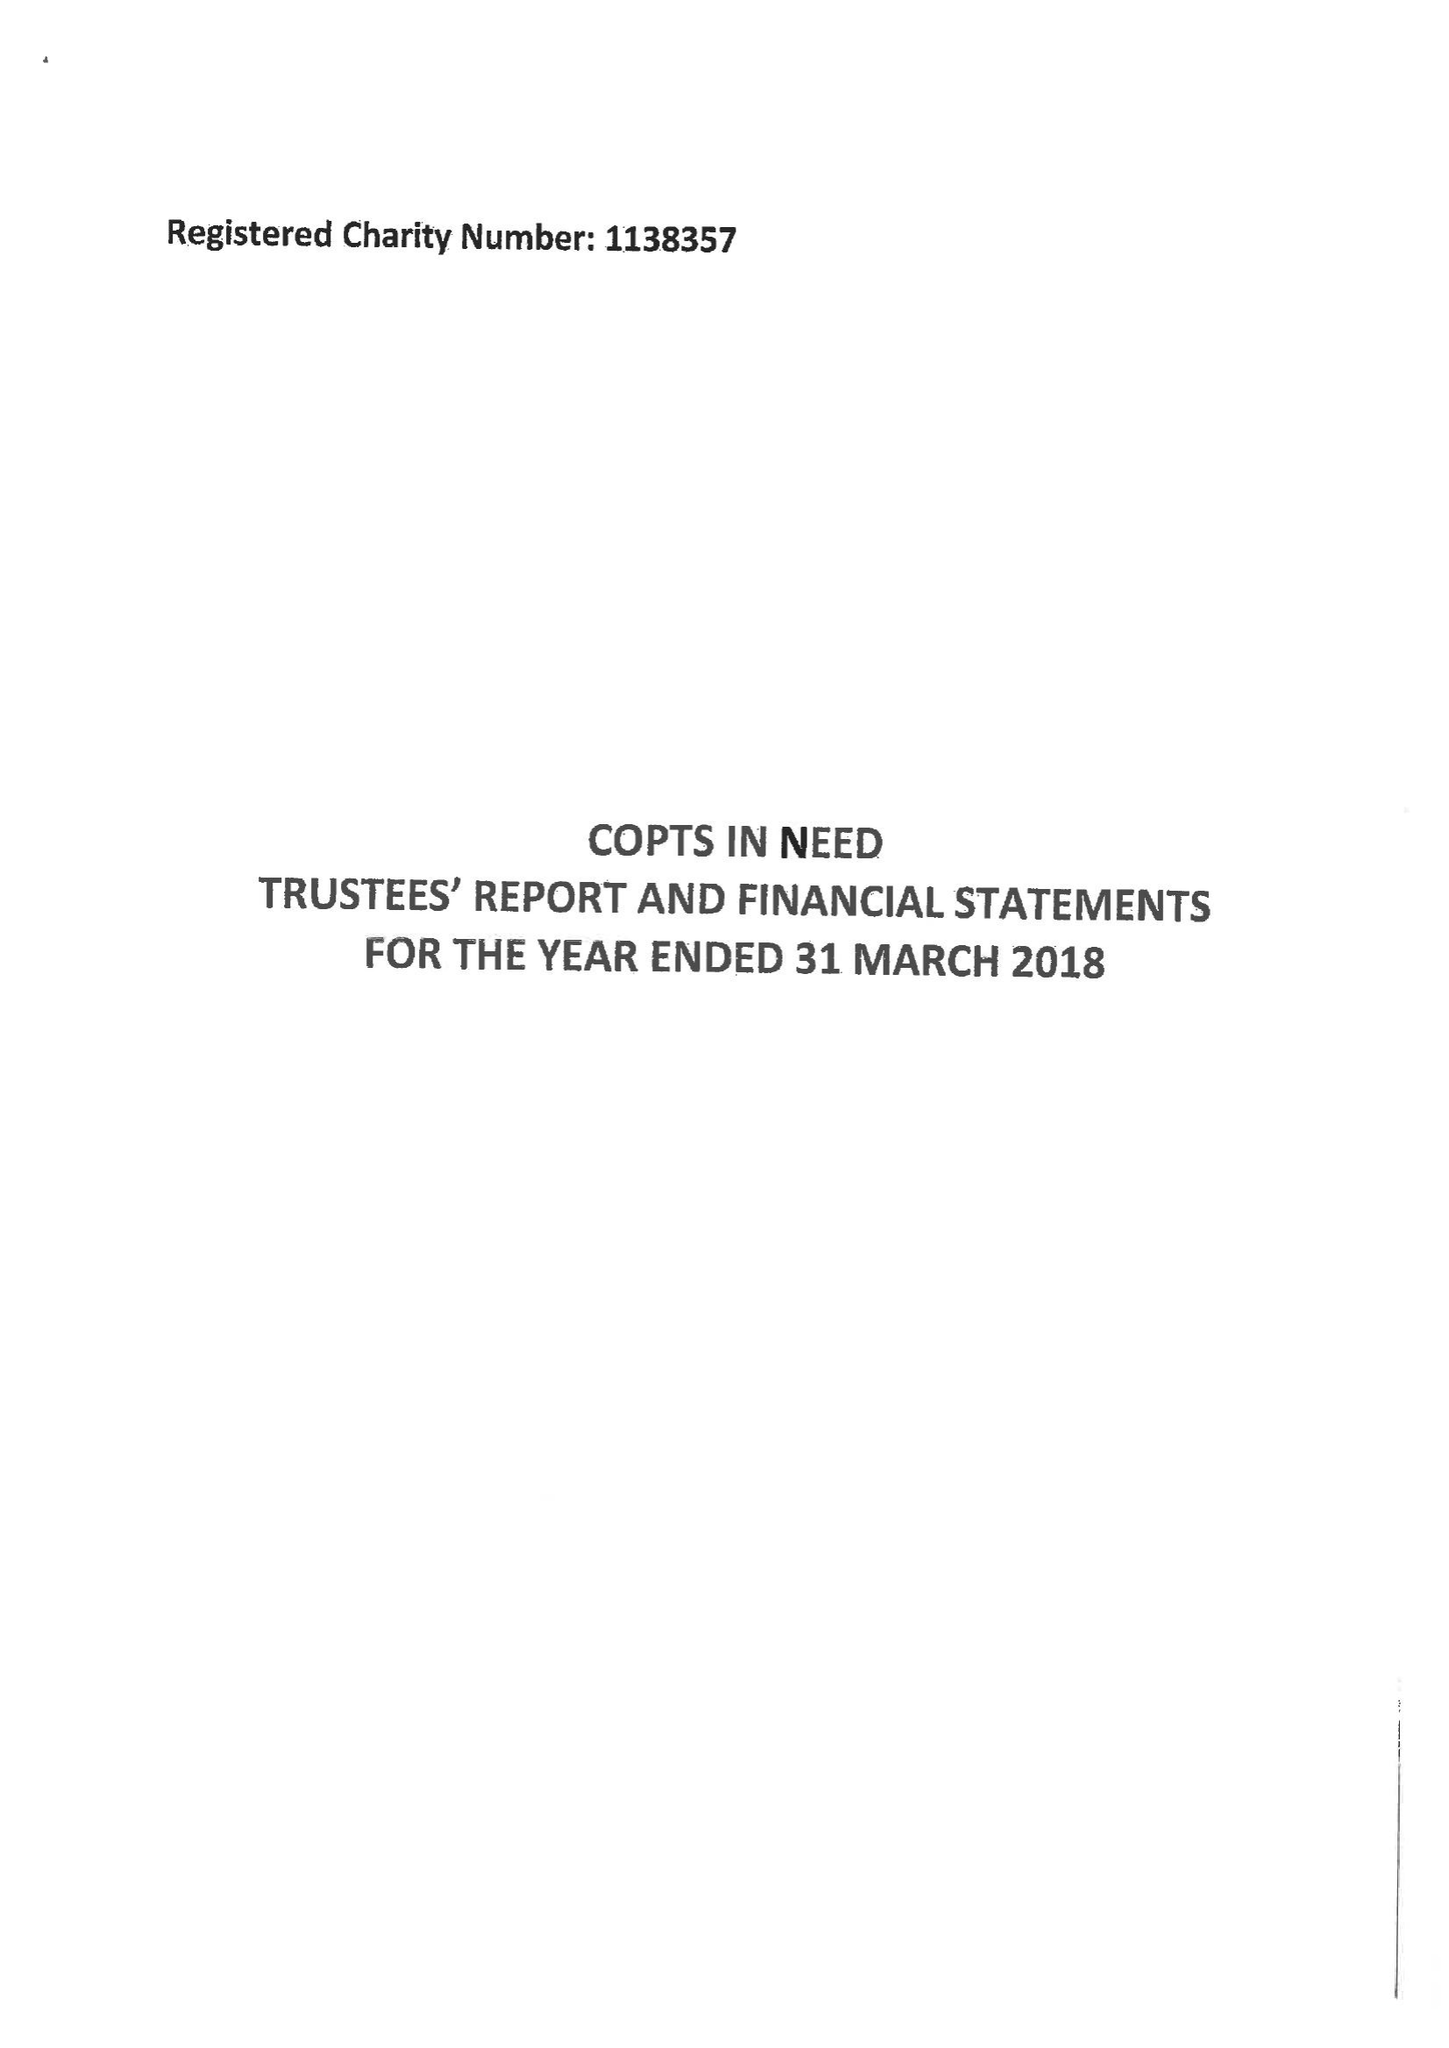What is the value for the spending_annually_in_british_pounds?
Answer the question using a single word or phrase. 312662.00 